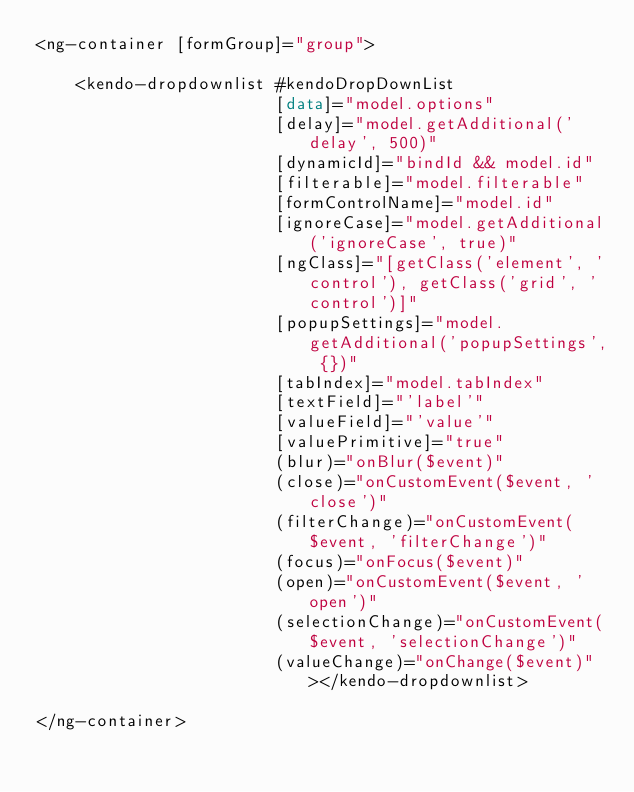<code> <loc_0><loc_0><loc_500><loc_500><_HTML_><ng-container [formGroup]="group">

    <kendo-dropdownlist #kendoDropDownList
                        [data]="model.options"
                        [delay]="model.getAdditional('delay', 500)"
                        [dynamicId]="bindId && model.id"
                        [filterable]="model.filterable"
                        [formControlName]="model.id"
                        [ignoreCase]="model.getAdditional('ignoreCase', true)"
                        [ngClass]="[getClass('element', 'control'), getClass('grid', 'control')]"
                        [popupSettings]="model.getAdditional('popupSettings', {})"
                        [tabIndex]="model.tabIndex"
                        [textField]="'label'"
                        [valueField]="'value'"
                        [valuePrimitive]="true"
                        (blur)="onBlur($event)"
                        (close)="onCustomEvent($event, 'close')"
                        (filterChange)="onCustomEvent($event, 'filterChange')"
                        (focus)="onFocus($event)"
                        (open)="onCustomEvent($event, 'open')"
                        (selectionChange)="onCustomEvent($event, 'selectionChange')"
                        (valueChange)="onChange($event)"></kendo-dropdownlist>

</ng-container></code> 